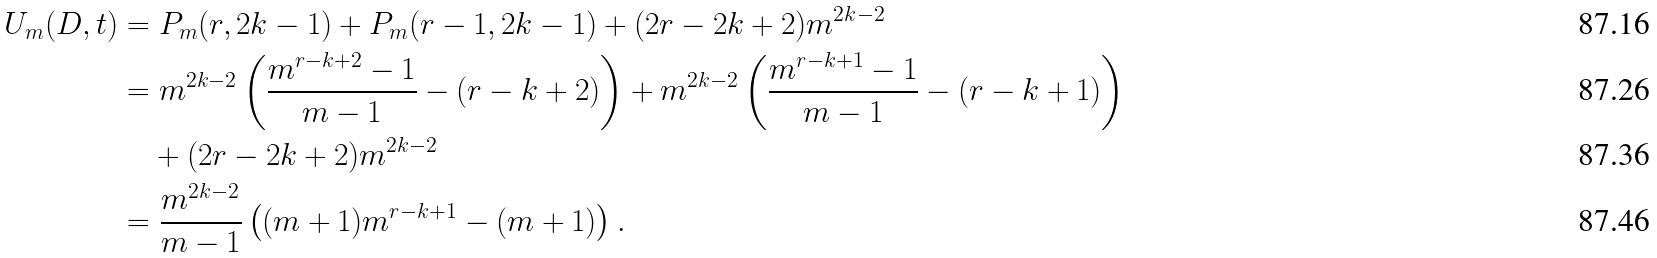<formula> <loc_0><loc_0><loc_500><loc_500>U _ { m } ( D , t ) & = P _ { m } ( r , 2 k - 1 ) + P _ { m } ( r - 1 , 2 k - 1 ) + ( 2 r - 2 k + 2 ) m ^ { 2 k - 2 } \\ & = m ^ { 2 k - 2 } \left ( \frac { m ^ { r - k + 2 } - 1 } { m - 1 } - ( r - k + 2 ) \right ) + m ^ { 2 k - 2 } \left ( \frac { m ^ { r - k + 1 } - 1 } { m - 1 } - ( r - k + 1 ) \right ) \\ & \quad + ( 2 r - 2 k + 2 ) m ^ { 2 k - 2 } \\ & = \frac { m ^ { 2 k - 2 } } { m - 1 } \left ( ( m + 1 ) m ^ { r - k + 1 } - ( m + 1 ) \right ) .</formula> 